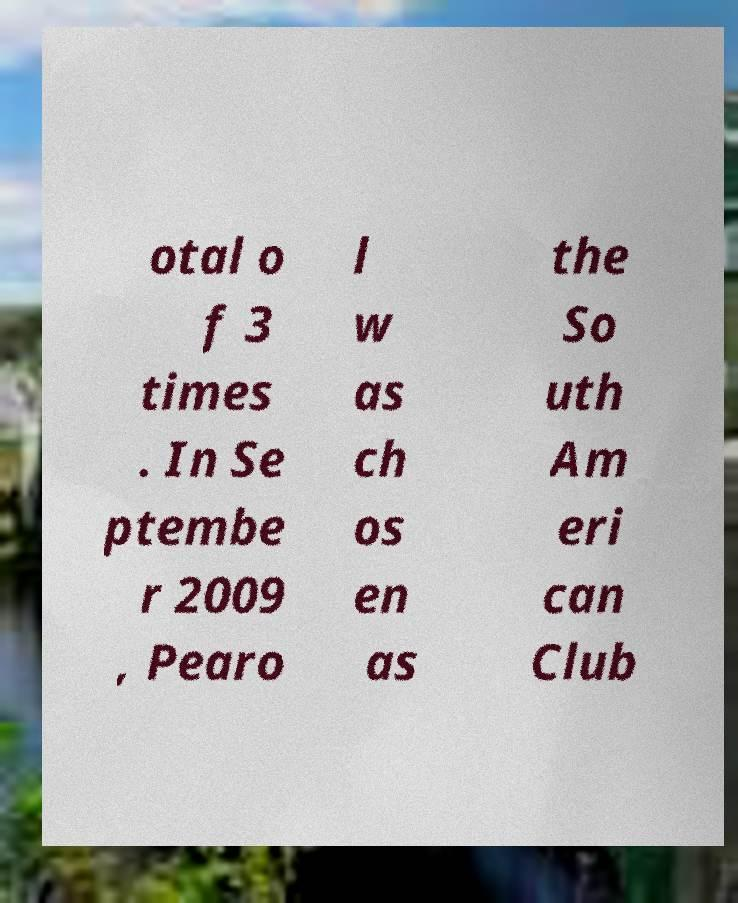Could you assist in decoding the text presented in this image and type it out clearly? otal o f 3 times . In Se ptembe r 2009 , Pearo l w as ch os en as the So uth Am eri can Club 